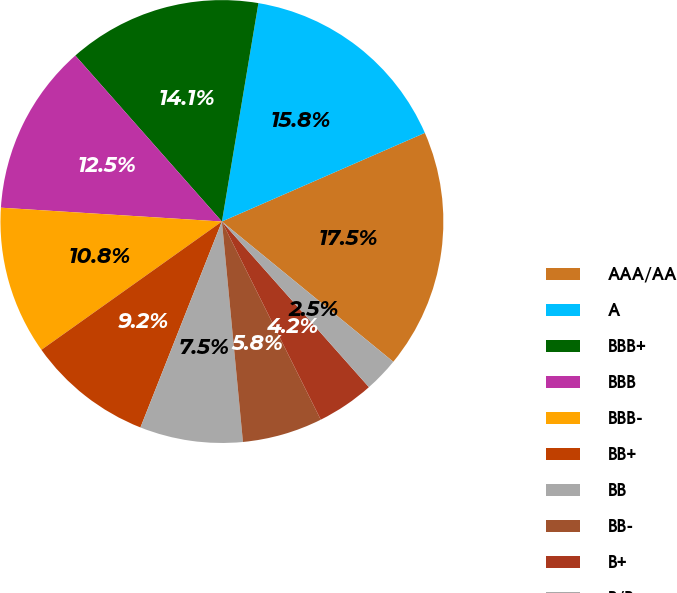Convert chart. <chart><loc_0><loc_0><loc_500><loc_500><pie_chart><fcel>AAA/AA<fcel>A<fcel>BBB+<fcel>BBB<fcel>BBB-<fcel>BB+<fcel>BB<fcel>BB-<fcel>B+<fcel>B/B-<nl><fcel>17.47%<fcel>15.81%<fcel>14.15%<fcel>12.49%<fcel>10.83%<fcel>9.17%<fcel>7.51%<fcel>5.85%<fcel>4.19%<fcel>2.53%<nl></chart> 